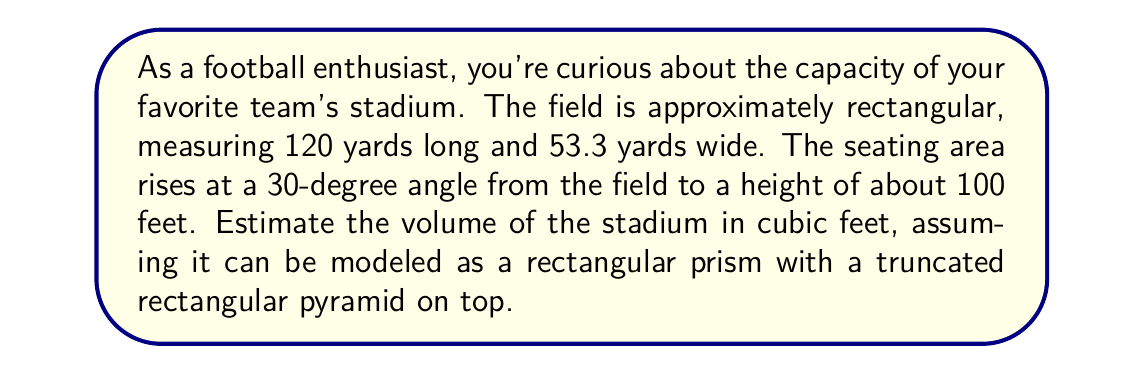Show me your answer to this math problem. Let's approach this step-by-step:

1) First, we need to convert all measurements to feet:
   120 yards = 360 feet
   53.3 yards ≈ 160 feet
   Height = 100 feet

2) The stadium can be divided into two parts:
   a) A rectangular prism (the field and space directly above it)
   b) A truncated rectangular pyramid (the seating area)

3) Volume of the rectangular prism:
   $$ V_1 = l \times w \times h = 360 \times 160 \times 100 = 5,760,000 \text{ ft}^3 $$

4) For the truncated pyramid, we need to find its base dimensions:
   Using trigonometry, the horizontal distance the seats extend is:
   $$ d = 100 \times \cot(30°) \approx 173 \text{ ft} $$

   So the base dimensions are:
   Length: $360 + 2(173) = 706 \text{ ft}$
   Width: $160 + 2(173) = 506 \text{ ft}$

5) Volume of a truncated pyramid:
   $$ V_2 = \frac{h}{3}(A_1 + A_2 + \sqrt{A_1A_2}) $$
   where $A_1$ is the area of the lower base and $A_2$ is the area of the upper base.

   $A_1 = 706 \times 506 = 357,236 \text{ ft}^2$
   $A_2 = 360 \times 160 = 57,600 \text{ ft}^2$

   $$ V_2 = \frac{100}{3}(357,236 + 57,600 + \sqrt{357,236 \times 57,600}) $$
   $$ V_2 \approx 15,764,533 \text{ ft}^3 $$

6) Total volume:
   $$ V_{total} = V_1 + V_2 = 5,760,000 + 15,764,533 = 21,524,533 \text{ ft}^3 $$

7) Rounding to the nearest million cubic feet:
   $$ V_{total} \approx 22,000,000 \text{ ft}^3 $$
Answer: $22,000,000 \text{ ft}^3$ 